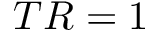Convert formula to latex. <formula><loc_0><loc_0><loc_500><loc_500>T R = 1</formula> 